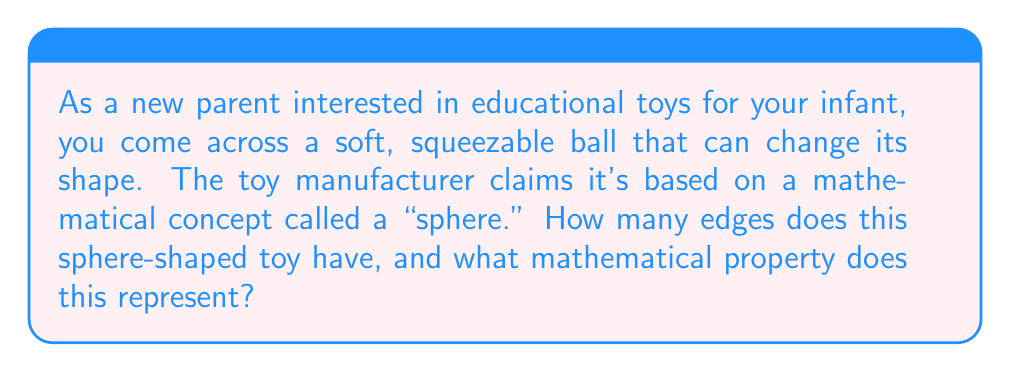Teach me how to tackle this problem. This question introduces the concept of a sphere, which is a fundamental example of a surface without edges in topology. Let's break down the explanation:

1. Definition of a sphere:
   A sphere is a three-dimensional surface where all points are equidistant from a central point. Mathematically, it can be described by the equation:

   $$ x^2 + y^2 + z^2 = r^2 $$

   where $r$ is the radius of the sphere.

2. Properties of a sphere:
   - A sphere is a closed surface, meaning it has no boundaries or edges.
   - It is continuous and smooth, with no breaks or sharp corners.
   - Topologically, a sphere is considered a 2-manifold, as it locally resembles a 2-dimensional plane at every point.

3. Edges on a sphere:
   - Unlike shapes such as cubes or pyramids, a sphere has no edges or vertices.
   - Every point on the surface of a sphere smoothly connects to its neighboring points without any discontinuities.

4. Topological significance:
   - The absence of edges makes the sphere a prime example of a surface without edges in topology.
   - This property allows for continuous deformations without creating or destroying edges, which is crucial in topological studies.

5. Relation to infant toys:
   - Soft, squeezable balls based on spheres are excellent educational toys for infants because:
     a. They are safe due to the absence of sharp edges.
     b. They introduce basic geometric concepts through tactile exploration.
     c. Their ability to change shape while maintaining topological properties can stimulate curiosity and spatial awareness.

The mathematical property represented by this edgeless toy is that of a "closed, boundaryless surface" in topology, which is a fundamental concept in the study of manifolds and continuous deformations.
Answer: The sphere-shaped toy has 0 edges, representing the topological property of a closed, boundaryless surface. 